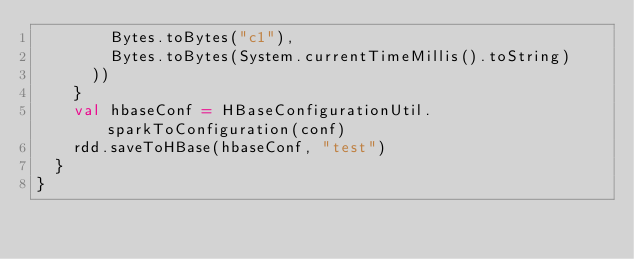Convert code to text. <code><loc_0><loc_0><loc_500><loc_500><_Scala_>        Bytes.toBytes("c1"),
        Bytes.toBytes(System.currentTimeMillis().toString)
      ))
    }
    val hbaseConf = HBaseConfigurationUtil.sparkToConfiguration(conf)
    rdd.saveToHBase(hbaseConf, "test")
  }
}
</code> 